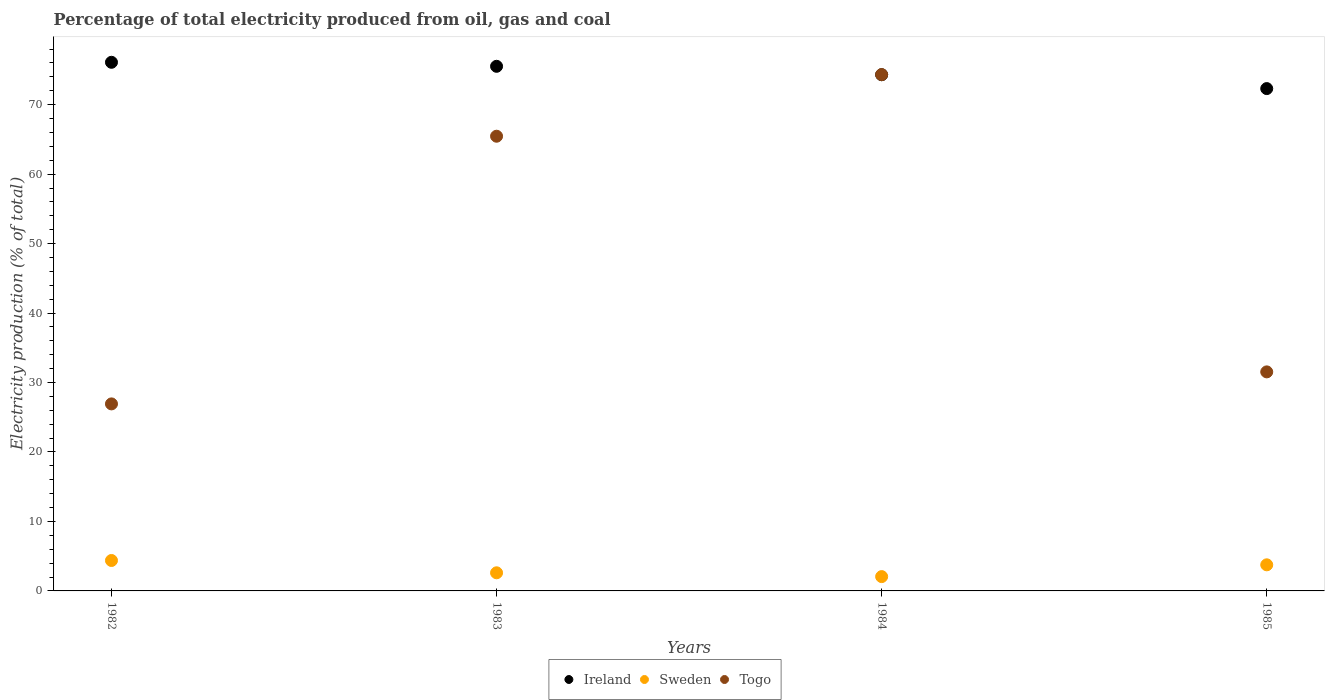Is the number of dotlines equal to the number of legend labels?
Ensure brevity in your answer.  Yes. What is the electricity production in in Togo in 1984?
Your response must be concise. 74.32. Across all years, what is the maximum electricity production in in Togo?
Your answer should be compact. 74.32. Across all years, what is the minimum electricity production in in Ireland?
Your response must be concise. 72.31. What is the total electricity production in in Sweden in the graph?
Provide a short and direct response. 12.81. What is the difference between the electricity production in in Sweden in 1982 and that in 1983?
Your answer should be compact. 1.77. What is the difference between the electricity production in in Ireland in 1985 and the electricity production in in Sweden in 1982?
Your response must be concise. 67.93. What is the average electricity production in in Ireland per year?
Keep it short and to the point. 74.56. In the year 1985, what is the difference between the electricity production in in Togo and electricity production in in Sweden?
Keep it short and to the point. 27.77. What is the ratio of the electricity production in in Togo in 1983 to that in 1985?
Your answer should be compact. 2.08. Is the electricity production in in Ireland in 1982 less than that in 1985?
Provide a succinct answer. No. Is the difference between the electricity production in in Togo in 1982 and 1983 greater than the difference between the electricity production in in Sweden in 1982 and 1983?
Keep it short and to the point. No. What is the difference between the highest and the second highest electricity production in in Ireland?
Ensure brevity in your answer.  0.58. What is the difference between the highest and the lowest electricity production in in Sweden?
Make the answer very short. 2.32. Is the sum of the electricity production in in Ireland in 1982 and 1983 greater than the maximum electricity production in in Sweden across all years?
Offer a terse response. Yes. Does the electricity production in in Sweden monotonically increase over the years?
Ensure brevity in your answer.  No. How many dotlines are there?
Your answer should be very brief. 3. Does the graph contain grids?
Give a very brief answer. No. Where does the legend appear in the graph?
Provide a succinct answer. Bottom center. How many legend labels are there?
Provide a short and direct response. 3. What is the title of the graph?
Provide a succinct answer. Percentage of total electricity produced from oil, gas and coal. What is the label or title of the Y-axis?
Keep it short and to the point. Electricity production (% of total). What is the Electricity production (% of total) in Ireland in 1982?
Your response must be concise. 76.1. What is the Electricity production (% of total) in Sweden in 1982?
Your answer should be very brief. 4.38. What is the Electricity production (% of total) in Togo in 1982?
Give a very brief answer. 26.92. What is the Electricity production (% of total) of Ireland in 1983?
Provide a short and direct response. 75.52. What is the Electricity production (% of total) of Sweden in 1983?
Provide a succinct answer. 2.61. What is the Electricity production (% of total) in Togo in 1983?
Make the answer very short. 65.45. What is the Electricity production (% of total) in Ireland in 1984?
Offer a terse response. 74.31. What is the Electricity production (% of total) of Sweden in 1984?
Give a very brief answer. 2.06. What is the Electricity production (% of total) of Togo in 1984?
Offer a terse response. 74.32. What is the Electricity production (% of total) in Ireland in 1985?
Make the answer very short. 72.31. What is the Electricity production (% of total) in Sweden in 1985?
Ensure brevity in your answer.  3.76. What is the Electricity production (% of total) in Togo in 1985?
Your response must be concise. 31.53. Across all years, what is the maximum Electricity production (% of total) in Ireland?
Give a very brief answer. 76.1. Across all years, what is the maximum Electricity production (% of total) in Sweden?
Provide a short and direct response. 4.38. Across all years, what is the maximum Electricity production (% of total) of Togo?
Provide a short and direct response. 74.32. Across all years, what is the minimum Electricity production (% of total) in Ireland?
Give a very brief answer. 72.31. Across all years, what is the minimum Electricity production (% of total) in Sweden?
Keep it short and to the point. 2.06. Across all years, what is the minimum Electricity production (% of total) in Togo?
Make the answer very short. 26.92. What is the total Electricity production (% of total) of Ireland in the graph?
Ensure brevity in your answer.  298.23. What is the total Electricity production (% of total) of Sweden in the graph?
Ensure brevity in your answer.  12.81. What is the total Electricity production (% of total) of Togo in the graph?
Offer a very short reply. 198.23. What is the difference between the Electricity production (% of total) in Ireland in 1982 and that in 1983?
Offer a terse response. 0.58. What is the difference between the Electricity production (% of total) of Sweden in 1982 and that in 1983?
Ensure brevity in your answer.  1.77. What is the difference between the Electricity production (% of total) in Togo in 1982 and that in 1983?
Your answer should be very brief. -38.53. What is the difference between the Electricity production (% of total) of Ireland in 1982 and that in 1984?
Ensure brevity in your answer.  1.79. What is the difference between the Electricity production (% of total) in Sweden in 1982 and that in 1984?
Give a very brief answer. 2.32. What is the difference between the Electricity production (% of total) of Togo in 1982 and that in 1984?
Offer a very short reply. -47.4. What is the difference between the Electricity production (% of total) of Ireland in 1982 and that in 1985?
Make the answer very short. 3.79. What is the difference between the Electricity production (% of total) of Sweden in 1982 and that in 1985?
Your response must be concise. 0.62. What is the difference between the Electricity production (% of total) of Togo in 1982 and that in 1985?
Give a very brief answer. -4.61. What is the difference between the Electricity production (% of total) of Ireland in 1983 and that in 1984?
Make the answer very short. 1.21. What is the difference between the Electricity production (% of total) in Sweden in 1983 and that in 1984?
Give a very brief answer. 0.55. What is the difference between the Electricity production (% of total) in Togo in 1983 and that in 1984?
Keep it short and to the point. -8.87. What is the difference between the Electricity production (% of total) in Ireland in 1983 and that in 1985?
Make the answer very short. 3.21. What is the difference between the Electricity production (% of total) of Sweden in 1983 and that in 1985?
Your answer should be compact. -1.15. What is the difference between the Electricity production (% of total) in Togo in 1983 and that in 1985?
Your response must be concise. 33.92. What is the difference between the Electricity production (% of total) of Ireland in 1984 and that in 1985?
Provide a succinct answer. 2. What is the difference between the Electricity production (% of total) in Sweden in 1984 and that in 1985?
Offer a terse response. -1.7. What is the difference between the Electricity production (% of total) of Togo in 1984 and that in 1985?
Your response must be concise. 42.79. What is the difference between the Electricity production (% of total) of Ireland in 1982 and the Electricity production (% of total) of Sweden in 1983?
Offer a very short reply. 73.49. What is the difference between the Electricity production (% of total) of Ireland in 1982 and the Electricity production (% of total) of Togo in 1983?
Your response must be concise. 10.64. What is the difference between the Electricity production (% of total) of Sweden in 1982 and the Electricity production (% of total) of Togo in 1983?
Your answer should be very brief. -61.07. What is the difference between the Electricity production (% of total) of Ireland in 1982 and the Electricity production (% of total) of Sweden in 1984?
Your response must be concise. 74.04. What is the difference between the Electricity production (% of total) of Ireland in 1982 and the Electricity production (% of total) of Togo in 1984?
Your answer should be very brief. 1.77. What is the difference between the Electricity production (% of total) of Sweden in 1982 and the Electricity production (% of total) of Togo in 1984?
Provide a succinct answer. -69.94. What is the difference between the Electricity production (% of total) in Ireland in 1982 and the Electricity production (% of total) in Sweden in 1985?
Keep it short and to the point. 72.34. What is the difference between the Electricity production (% of total) of Ireland in 1982 and the Electricity production (% of total) of Togo in 1985?
Your answer should be very brief. 44.57. What is the difference between the Electricity production (% of total) in Sweden in 1982 and the Electricity production (% of total) in Togo in 1985?
Make the answer very short. -27.15. What is the difference between the Electricity production (% of total) in Ireland in 1983 and the Electricity production (% of total) in Sweden in 1984?
Provide a succinct answer. 73.46. What is the difference between the Electricity production (% of total) of Ireland in 1983 and the Electricity production (% of total) of Togo in 1984?
Your response must be concise. 1.2. What is the difference between the Electricity production (% of total) of Sweden in 1983 and the Electricity production (% of total) of Togo in 1984?
Ensure brevity in your answer.  -71.72. What is the difference between the Electricity production (% of total) in Ireland in 1983 and the Electricity production (% of total) in Sweden in 1985?
Provide a succinct answer. 71.76. What is the difference between the Electricity production (% of total) in Ireland in 1983 and the Electricity production (% of total) in Togo in 1985?
Your answer should be very brief. 43.99. What is the difference between the Electricity production (% of total) of Sweden in 1983 and the Electricity production (% of total) of Togo in 1985?
Provide a succinct answer. -28.92. What is the difference between the Electricity production (% of total) of Ireland in 1984 and the Electricity production (% of total) of Sweden in 1985?
Your answer should be very brief. 70.55. What is the difference between the Electricity production (% of total) of Ireland in 1984 and the Electricity production (% of total) of Togo in 1985?
Offer a very short reply. 42.77. What is the difference between the Electricity production (% of total) of Sweden in 1984 and the Electricity production (% of total) of Togo in 1985?
Make the answer very short. -29.47. What is the average Electricity production (% of total) of Ireland per year?
Ensure brevity in your answer.  74.56. What is the average Electricity production (% of total) in Sweden per year?
Make the answer very short. 3.2. What is the average Electricity production (% of total) in Togo per year?
Offer a terse response. 49.56. In the year 1982, what is the difference between the Electricity production (% of total) in Ireland and Electricity production (% of total) in Sweden?
Provide a succinct answer. 71.72. In the year 1982, what is the difference between the Electricity production (% of total) in Ireland and Electricity production (% of total) in Togo?
Make the answer very short. 49.17. In the year 1982, what is the difference between the Electricity production (% of total) in Sweden and Electricity production (% of total) in Togo?
Your answer should be compact. -22.54. In the year 1983, what is the difference between the Electricity production (% of total) of Ireland and Electricity production (% of total) of Sweden?
Your answer should be very brief. 72.91. In the year 1983, what is the difference between the Electricity production (% of total) in Ireland and Electricity production (% of total) in Togo?
Ensure brevity in your answer.  10.06. In the year 1983, what is the difference between the Electricity production (% of total) of Sweden and Electricity production (% of total) of Togo?
Your response must be concise. -62.85. In the year 1984, what is the difference between the Electricity production (% of total) of Ireland and Electricity production (% of total) of Sweden?
Your response must be concise. 72.25. In the year 1984, what is the difference between the Electricity production (% of total) in Ireland and Electricity production (% of total) in Togo?
Keep it short and to the point. -0.02. In the year 1984, what is the difference between the Electricity production (% of total) in Sweden and Electricity production (% of total) in Togo?
Provide a short and direct response. -72.26. In the year 1985, what is the difference between the Electricity production (% of total) of Ireland and Electricity production (% of total) of Sweden?
Your answer should be compact. 68.55. In the year 1985, what is the difference between the Electricity production (% of total) of Ireland and Electricity production (% of total) of Togo?
Your answer should be very brief. 40.78. In the year 1985, what is the difference between the Electricity production (% of total) in Sweden and Electricity production (% of total) in Togo?
Provide a short and direct response. -27.77. What is the ratio of the Electricity production (% of total) in Ireland in 1982 to that in 1983?
Provide a succinct answer. 1.01. What is the ratio of the Electricity production (% of total) in Sweden in 1982 to that in 1983?
Provide a short and direct response. 1.68. What is the ratio of the Electricity production (% of total) of Togo in 1982 to that in 1983?
Offer a terse response. 0.41. What is the ratio of the Electricity production (% of total) in Ireland in 1982 to that in 1984?
Give a very brief answer. 1.02. What is the ratio of the Electricity production (% of total) in Sweden in 1982 to that in 1984?
Provide a short and direct response. 2.13. What is the ratio of the Electricity production (% of total) of Togo in 1982 to that in 1984?
Offer a terse response. 0.36. What is the ratio of the Electricity production (% of total) of Ireland in 1982 to that in 1985?
Offer a terse response. 1.05. What is the ratio of the Electricity production (% of total) of Sweden in 1982 to that in 1985?
Your answer should be compact. 1.17. What is the ratio of the Electricity production (% of total) in Togo in 1982 to that in 1985?
Provide a short and direct response. 0.85. What is the ratio of the Electricity production (% of total) in Ireland in 1983 to that in 1984?
Make the answer very short. 1.02. What is the ratio of the Electricity production (% of total) in Sweden in 1983 to that in 1984?
Provide a short and direct response. 1.27. What is the ratio of the Electricity production (% of total) of Togo in 1983 to that in 1984?
Your response must be concise. 0.88. What is the ratio of the Electricity production (% of total) of Ireland in 1983 to that in 1985?
Provide a short and direct response. 1.04. What is the ratio of the Electricity production (% of total) in Sweden in 1983 to that in 1985?
Make the answer very short. 0.69. What is the ratio of the Electricity production (% of total) in Togo in 1983 to that in 1985?
Provide a short and direct response. 2.08. What is the ratio of the Electricity production (% of total) of Ireland in 1984 to that in 1985?
Your answer should be compact. 1.03. What is the ratio of the Electricity production (% of total) in Sweden in 1984 to that in 1985?
Keep it short and to the point. 0.55. What is the ratio of the Electricity production (% of total) of Togo in 1984 to that in 1985?
Your response must be concise. 2.36. What is the difference between the highest and the second highest Electricity production (% of total) of Ireland?
Offer a very short reply. 0.58. What is the difference between the highest and the second highest Electricity production (% of total) in Sweden?
Give a very brief answer. 0.62. What is the difference between the highest and the second highest Electricity production (% of total) in Togo?
Offer a very short reply. 8.87. What is the difference between the highest and the lowest Electricity production (% of total) of Ireland?
Offer a very short reply. 3.79. What is the difference between the highest and the lowest Electricity production (% of total) of Sweden?
Provide a short and direct response. 2.32. What is the difference between the highest and the lowest Electricity production (% of total) of Togo?
Keep it short and to the point. 47.4. 